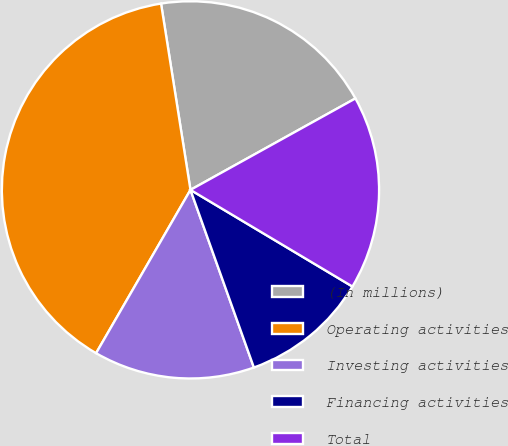Convert chart. <chart><loc_0><loc_0><loc_500><loc_500><pie_chart><fcel>(In millions)<fcel>Operating activities<fcel>Investing activities<fcel>Financing activities<fcel>Total<nl><fcel>19.44%<fcel>39.17%<fcel>13.8%<fcel>10.98%<fcel>16.62%<nl></chart> 